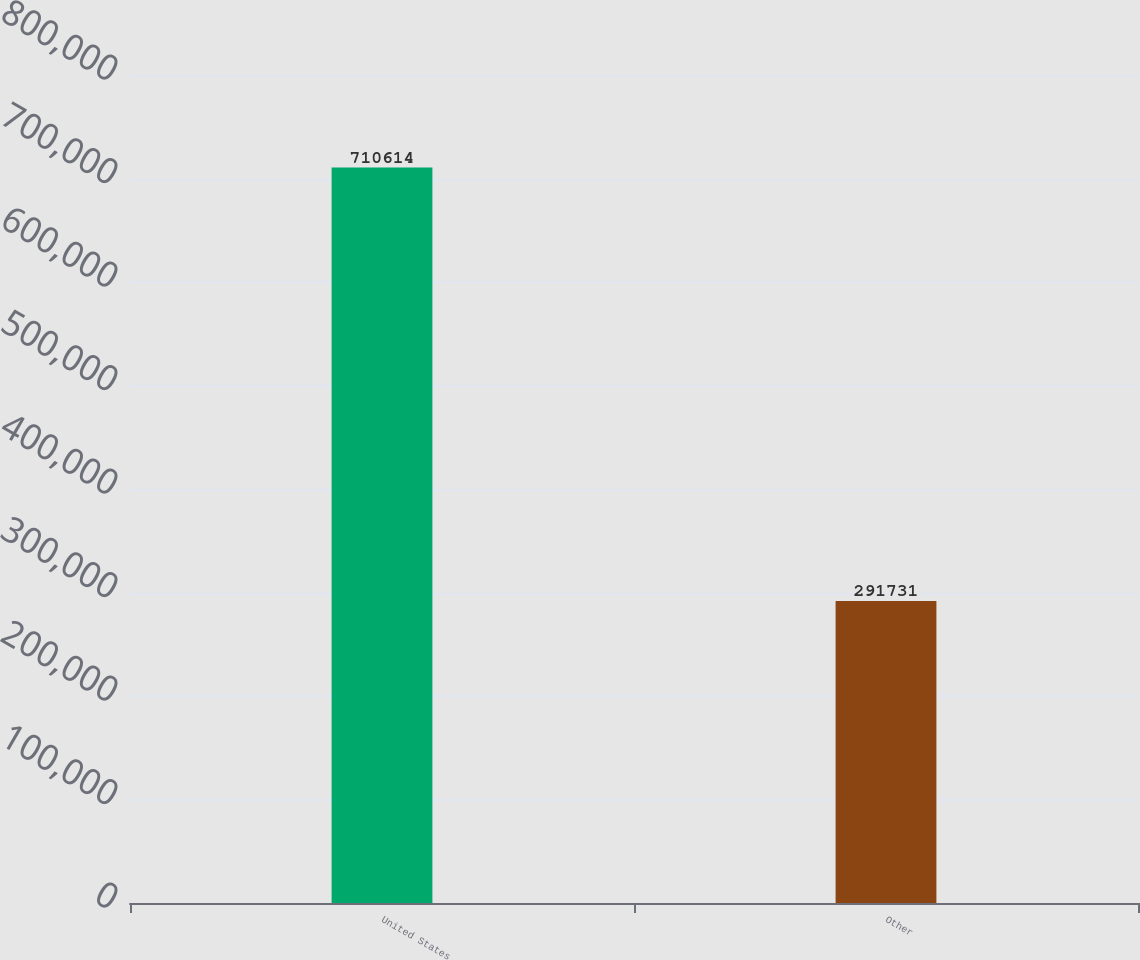Convert chart. <chart><loc_0><loc_0><loc_500><loc_500><bar_chart><fcel>United States<fcel>Other<nl><fcel>710614<fcel>291731<nl></chart> 